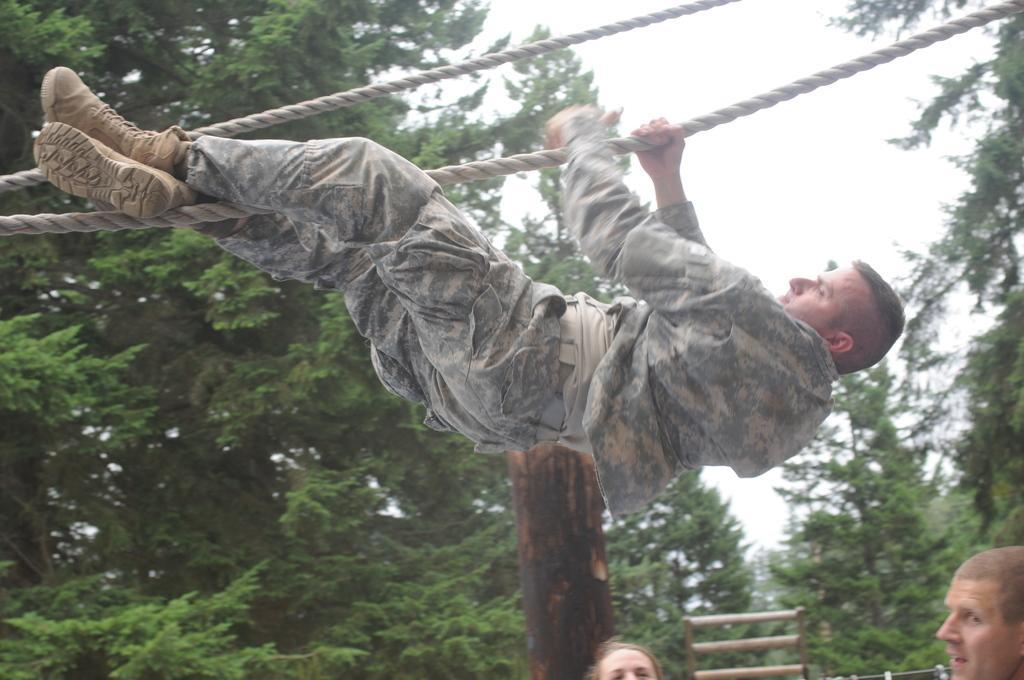How would you summarize this image in a sentence or two? In this image we can see few persons, one of them is hanging on the rope and there is a wooden pole and sticks, also we can see the sky, and some trees. 